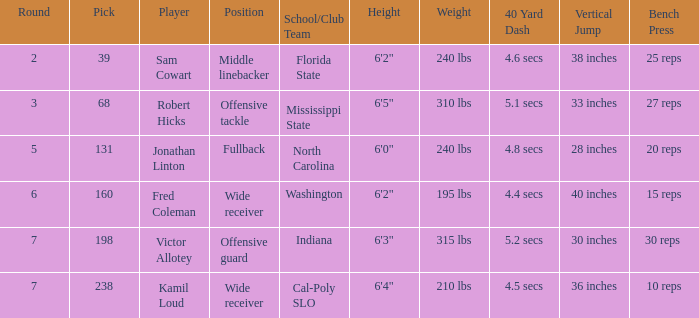Parse the full table. {'header': ['Round', 'Pick', 'Player', 'Position', 'School/Club Team', 'Height', 'Weight', '40 Yard Dash', 'Vertical Jump', 'Bench Press'], 'rows': [['2', '39', 'Sam Cowart', 'Middle linebacker', 'Florida State', '6\'2"', '240 lbs', '4.6 secs', '38 inches', '25 reps'], ['3', '68', 'Robert Hicks', 'Offensive tackle', 'Mississippi State', '6\'5"', '310 lbs', '5.1 secs', '33 inches', '27 reps'], ['5', '131', 'Jonathan Linton', 'Fullback', 'North Carolina', '6\'0"', '240 lbs', '4.8 secs', '28 inches', '20 reps'], ['6', '160', 'Fred Coleman', 'Wide receiver', 'Washington', '6\'2"', '195 lbs', '4.4 secs', '40 inches', '15 reps'], ['7', '198', 'Victor Allotey', 'Offensive guard', 'Indiana', '6\'3"', '315 lbs', '5.2 secs', '30 inches', '30 reps '], ['7', '238', 'Kamil Loud', 'Wide receiver', 'Cal-Poly SLO', '6\'4"', '210 lbs', '4.5 secs', '36 inches', '10 reps']]} Which Round has a School/Club Team of north carolina, and a Pick larger than 131? 0.0. 